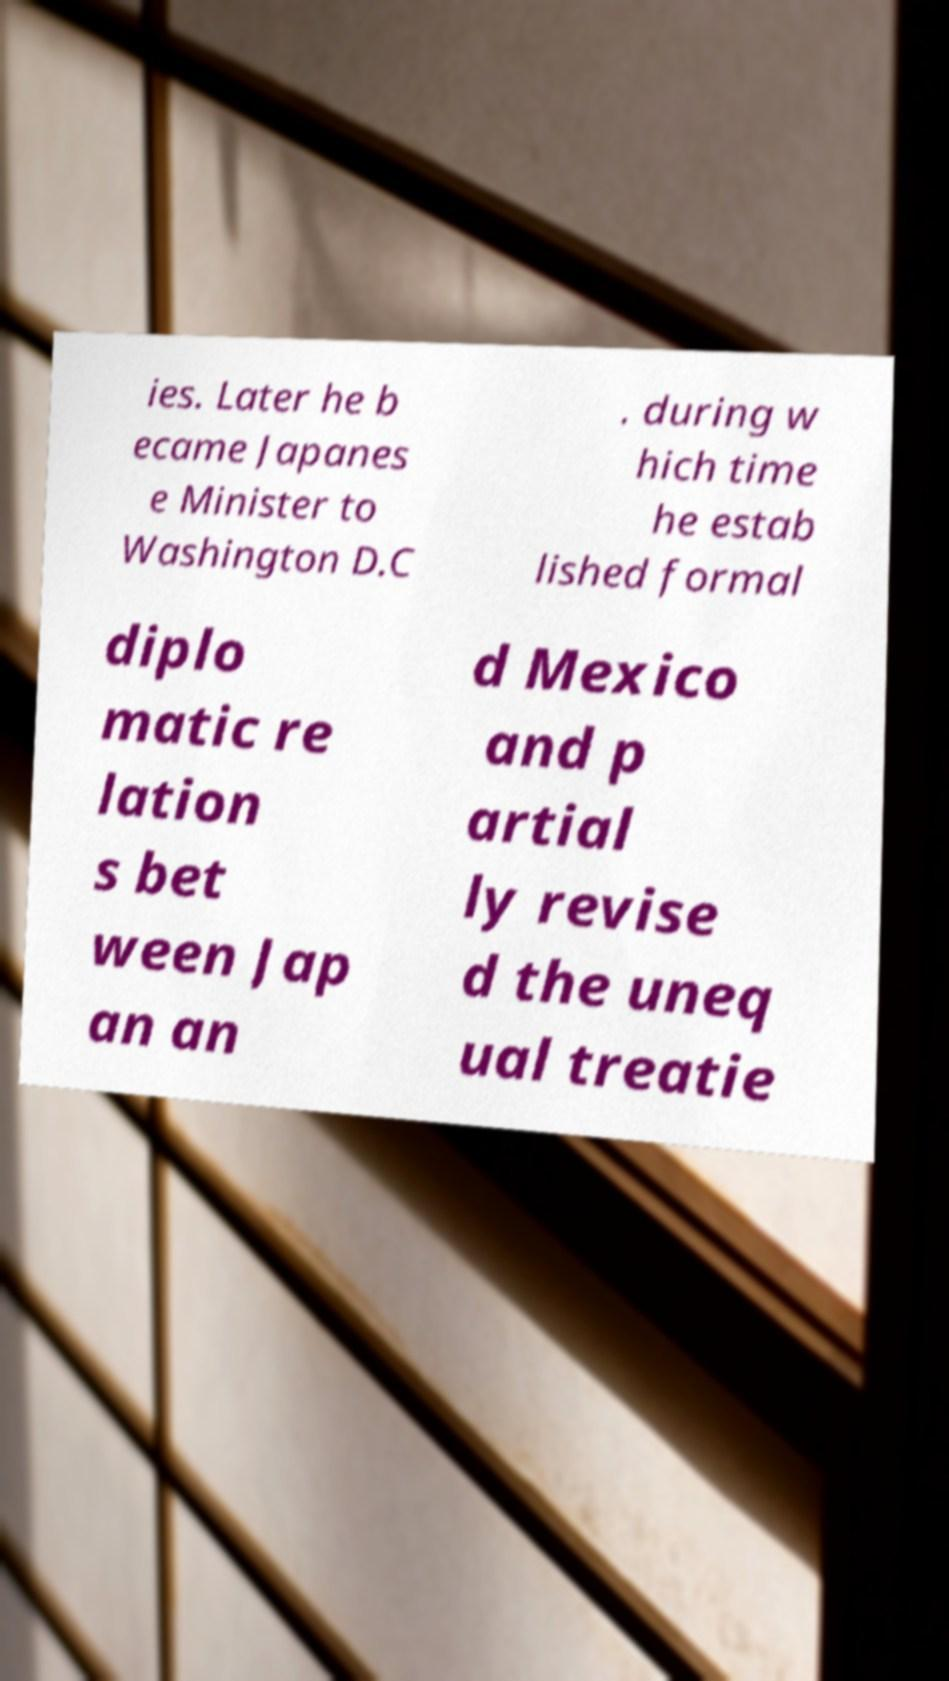What messages or text are displayed in this image? I need them in a readable, typed format. ies. Later he b ecame Japanes e Minister to Washington D.C . during w hich time he estab lished formal diplo matic re lation s bet ween Jap an an d Mexico and p artial ly revise d the uneq ual treatie 